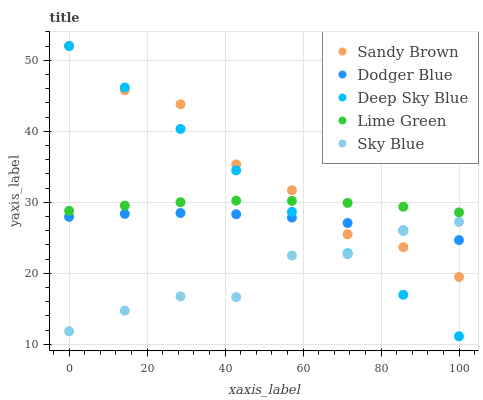Does Sky Blue have the minimum area under the curve?
Answer yes or no. Yes. Does Sandy Brown have the maximum area under the curve?
Answer yes or no. Yes. Does Dodger Blue have the minimum area under the curve?
Answer yes or no. No. Does Dodger Blue have the maximum area under the curve?
Answer yes or no. No. Is Deep Sky Blue the smoothest?
Answer yes or no. Yes. Is Sandy Brown the roughest?
Answer yes or no. Yes. Is Dodger Blue the smoothest?
Answer yes or no. No. Is Dodger Blue the roughest?
Answer yes or no. No. Does Deep Sky Blue have the lowest value?
Answer yes or no. Yes. Does Dodger Blue have the lowest value?
Answer yes or no. No. Does Deep Sky Blue have the highest value?
Answer yes or no. Yes. Does Dodger Blue have the highest value?
Answer yes or no. No. Is Dodger Blue less than Lime Green?
Answer yes or no. Yes. Is Lime Green greater than Dodger Blue?
Answer yes or no. Yes. Does Deep Sky Blue intersect Lime Green?
Answer yes or no. Yes. Is Deep Sky Blue less than Lime Green?
Answer yes or no. No. Is Deep Sky Blue greater than Lime Green?
Answer yes or no. No. Does Dodger Blue intersect Lime Green?
Answer yes or no. No. 